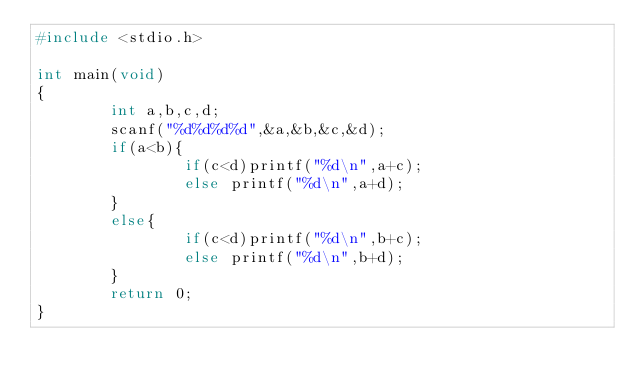<code> <loc_0><loc_0><loc_500><loc_500><_C_>#include <stdio.h>

int main(void)
{
        int a,b,c,d;
        scanf("%d%d%d%d",&a,&b,&c,&d);
        if(a<b){
                if(c<d)printf("%d\n",a+c);
                else printf("%d\n",a+d);
        }
        else{
                if(c<d)printf("%d\n",b+c);
                else printf("%d\n",b+d);
        }
        return 0;
}
</code> 